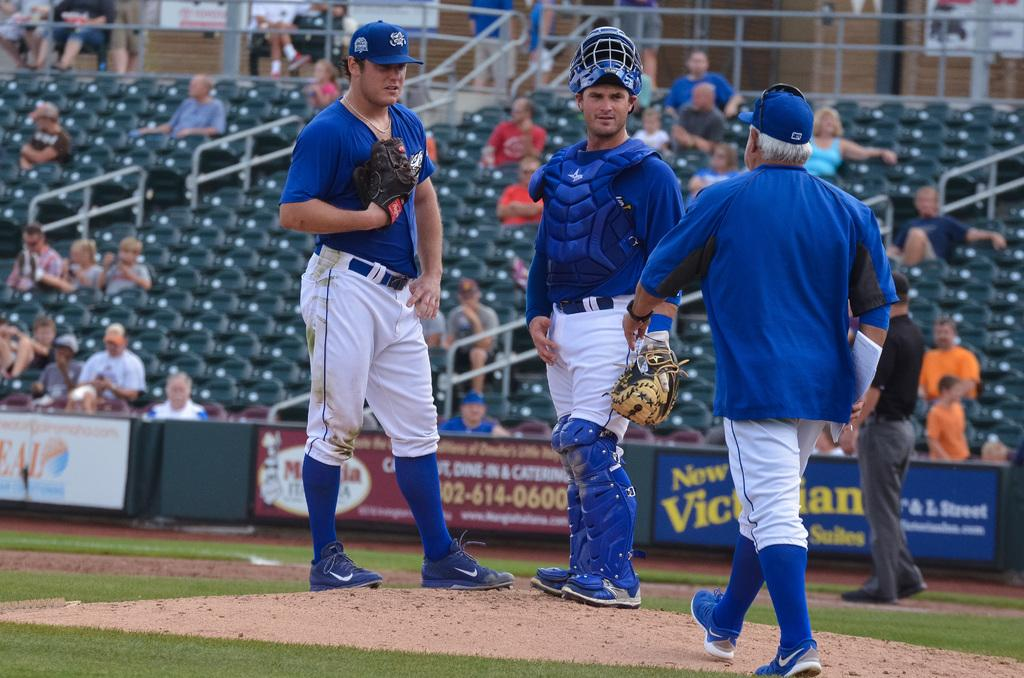<image>
Describe the image concisely. Baseball players are on a field that has a New Victorian sign in the background. 